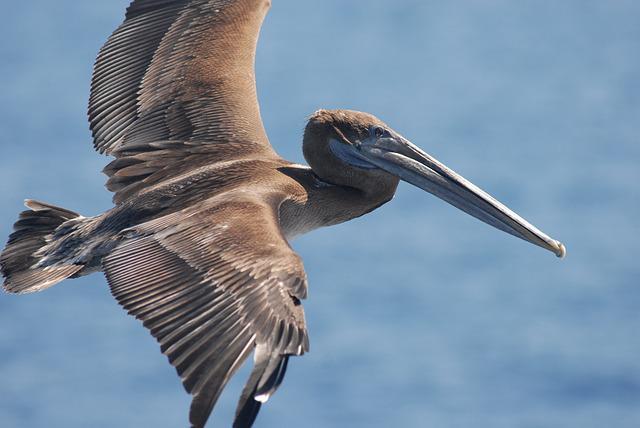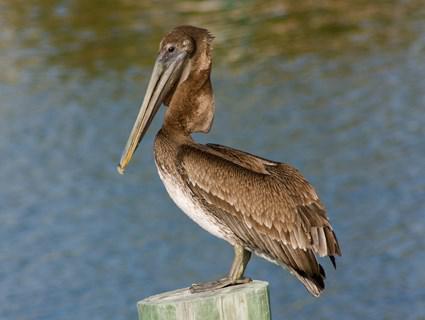The first image is the image on the left, the second image is the image on the right. Evaluate the accuracy of this statement regarding the images: "There is one flying bird.". Is it true? Answer yes or no. Yes. 